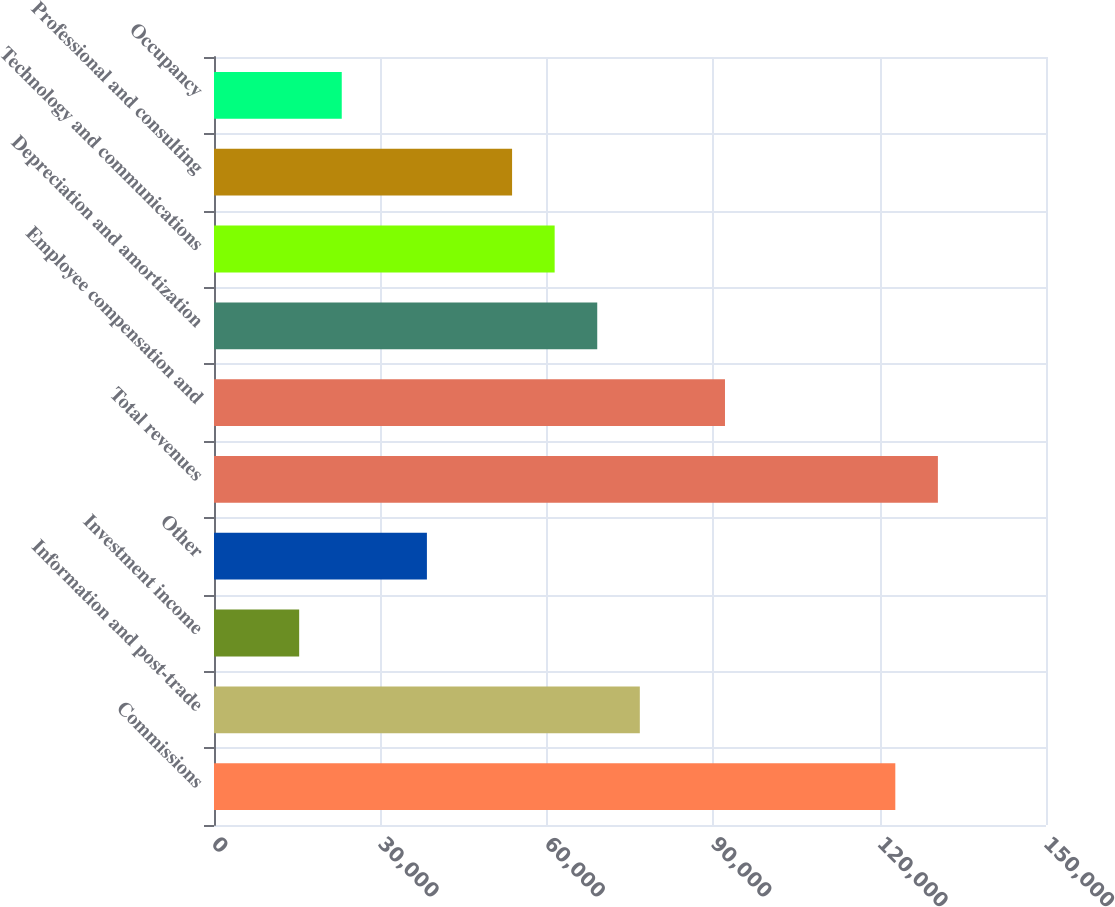Convert chart to OTSL. <chart><loc_0><loc_0><loc_500><loc_500><bar_chart><fcel>Commissions<fcel>Information and post-trade<fcel>Investment income<fcel>Other<fcel>Total revenues<fcel>Employee compensation and<fcel>Depreciation and amortization<fcel>Technology and communications<fcel>Professional and consulting<fcel>Occupancy<nl><fcel>122833<fcel>76771<fcel>15354.7<fcel>38385.8<fcel>130510<fcel>92125.1<fcel>69094<fcel>61416.9<fcel>53739.9<fcel>23031.8<nl></chart> 